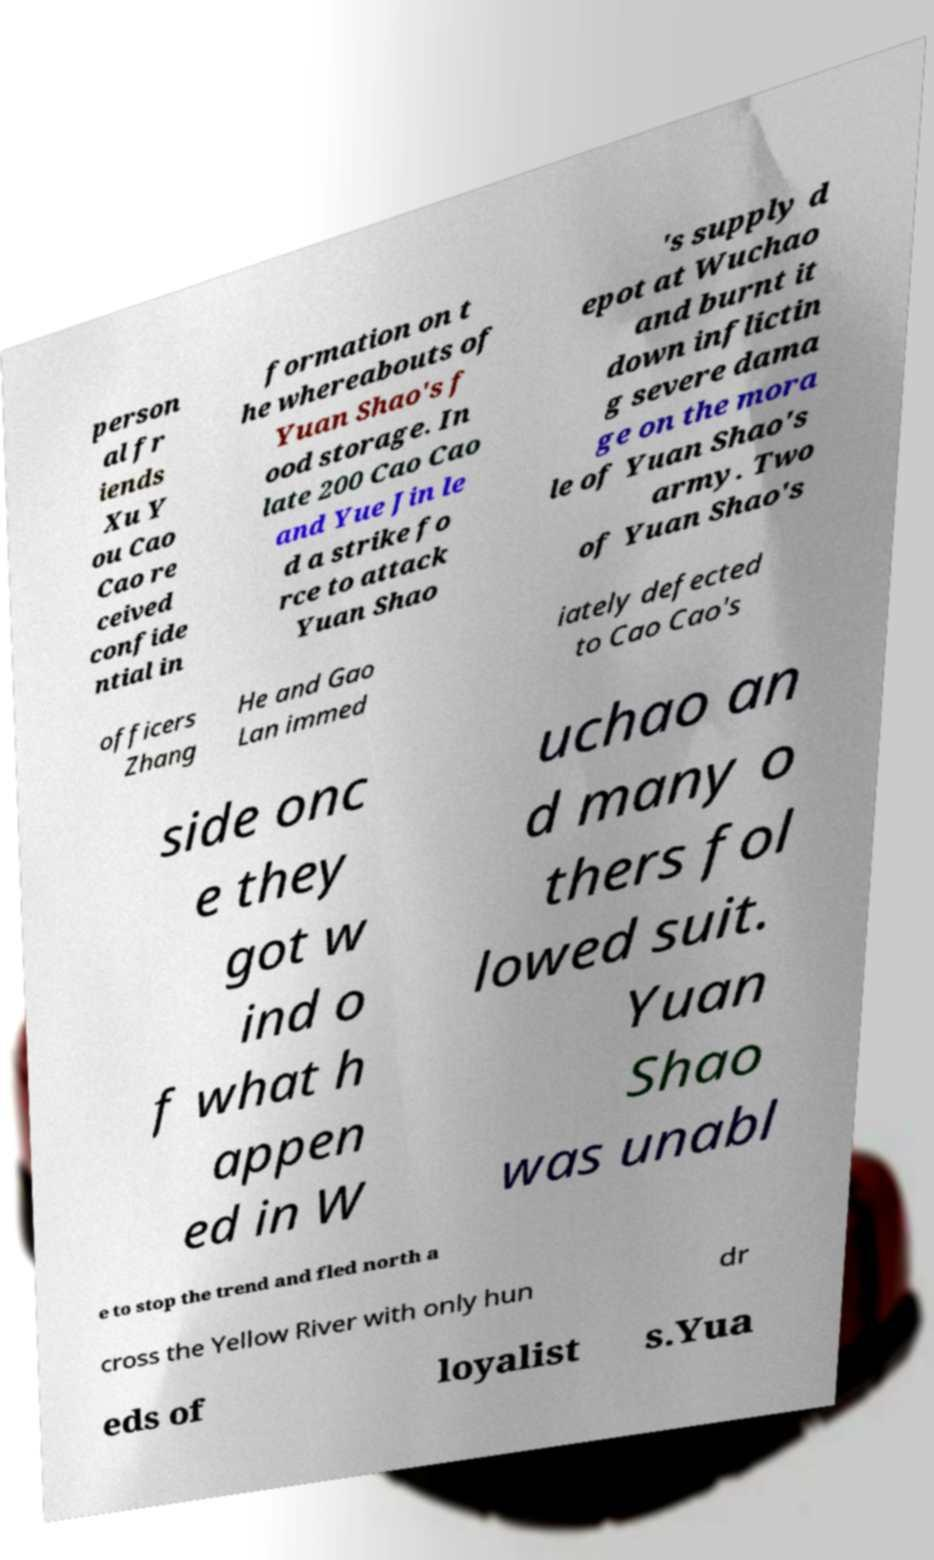I need the written content from this picture converted into text. Can you do that? person al fr iends Xu Y ou Cao Cao re ceived confide ntial in formation on t he whereabouts of Yuan Shao's f ood storage. In late 200 Cao Cao and Yue Jin le d a strike fo rce to attack Yuan Shao 's supply d epot at Wuchao and burnt it down inflictin g severe dama ge on the mora le of Yuan Shao's army. Two of Yuan Shao's officers Zhang He and Gao Lan immed iately defected to Cao Cao's side onc e they got w ind o f what h appen ed in W uchao an d many o thers fol lowed suit. Yuan Shao was unabl e to stop the trend and fled north a cross the Yellow River with only hun dr eds of loyalist s.Yua 